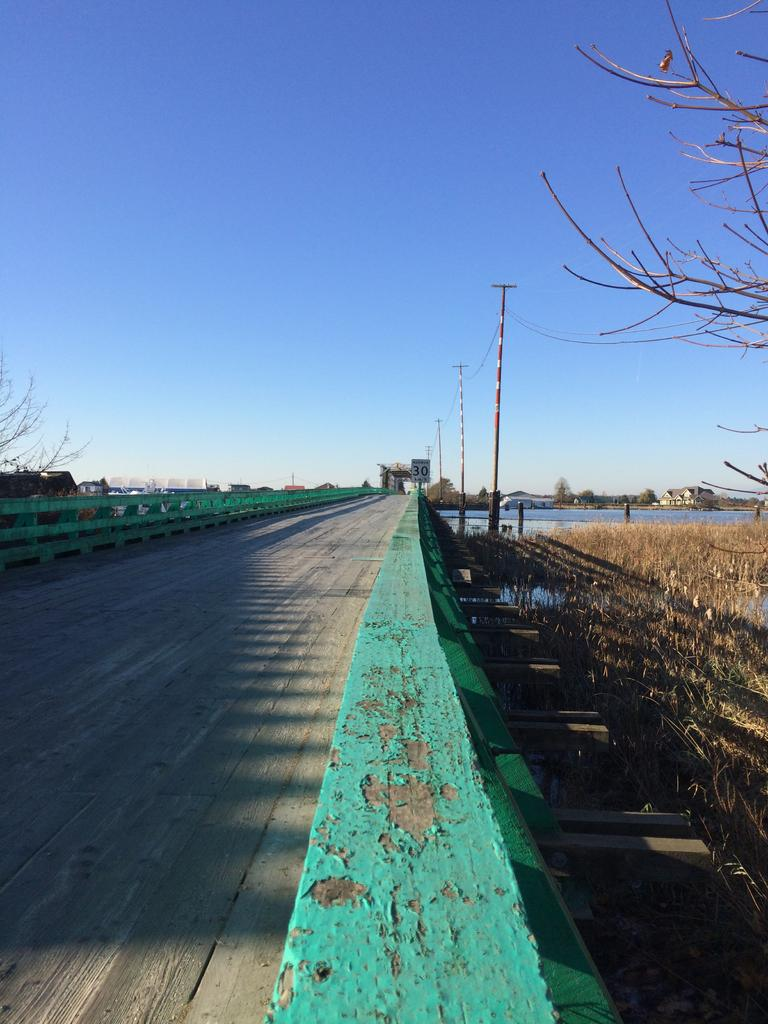What structure is located on the left side of the image? There is a bridge on the left side of the image. What type of vegetation is on the right side of the image? There is grass and a tree on the right side of the image. What can be seen in the background of the image? There are poles, water, and the sky visible in the background of the image. How many babies are present in the image? There are no babies present in the image. What type of picture is hanging on the tree in the image? There is no picture hanging on the tree in the image; it is a tree with grass on the right side of the image. 